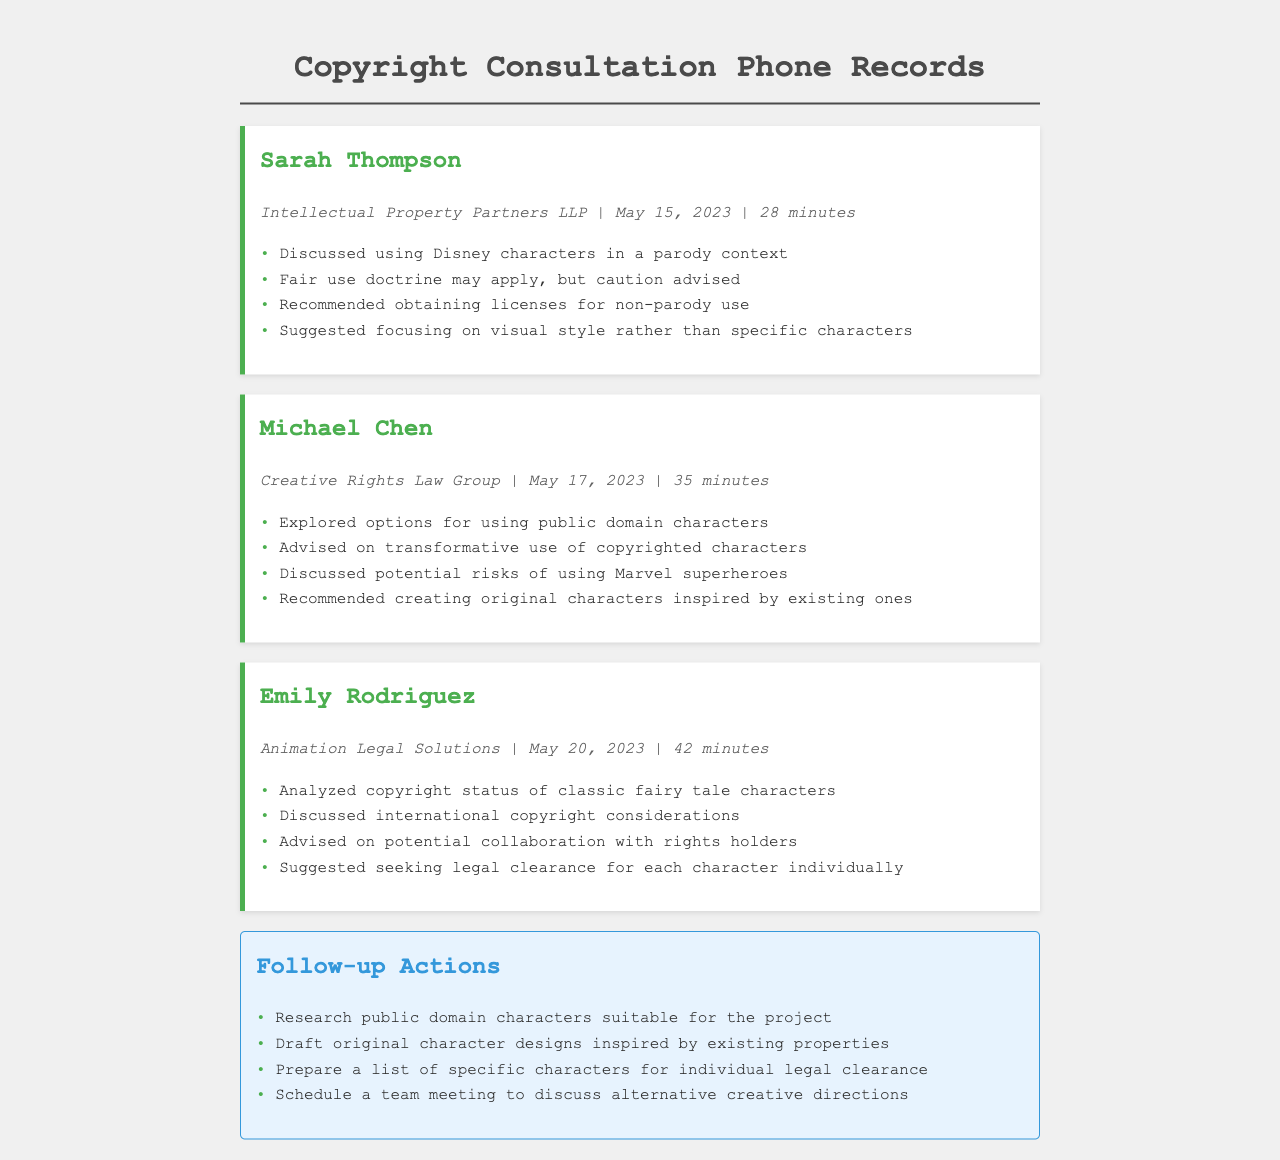What is the name of the first lawyer consulted? The first lawyer consulted is mentioned at the top of the first call record.
Answer: Sarah Thompson When did the consultation with Michael Chen occur? The document specifies the date next to the call record for Michael Chen.
Answer: May 17, 2023 How long was the consultation with Emily Rodriguez? The duration of the call with Emily Rodriguez is listed in her call record.
Answer: 42 minutes What does the document suggest regarding using Disney characters? The specific advice regarding Disney characters is outlined in the first call record.
Answer: Caution advised What was one of the follow-up actions recommended in the document? The follow-up actions are listed at the bottom of the document, providing concise tasks.
Answer: Research public domain characters suitable for the project What law group did Michael Chen represent? The law group is indicated in the call record under Michael Chen's name.
Answer: Creative Rights Law Group Which characters did Emily Rodriguez analyze? The characters are specified in the context of her discussion in the call record.
Answer: Classic fairy tale characters What is the main topic of the telephone records? The overarching theme can be deduced from the title and the content of the records.
Answer: Copyright consultations 